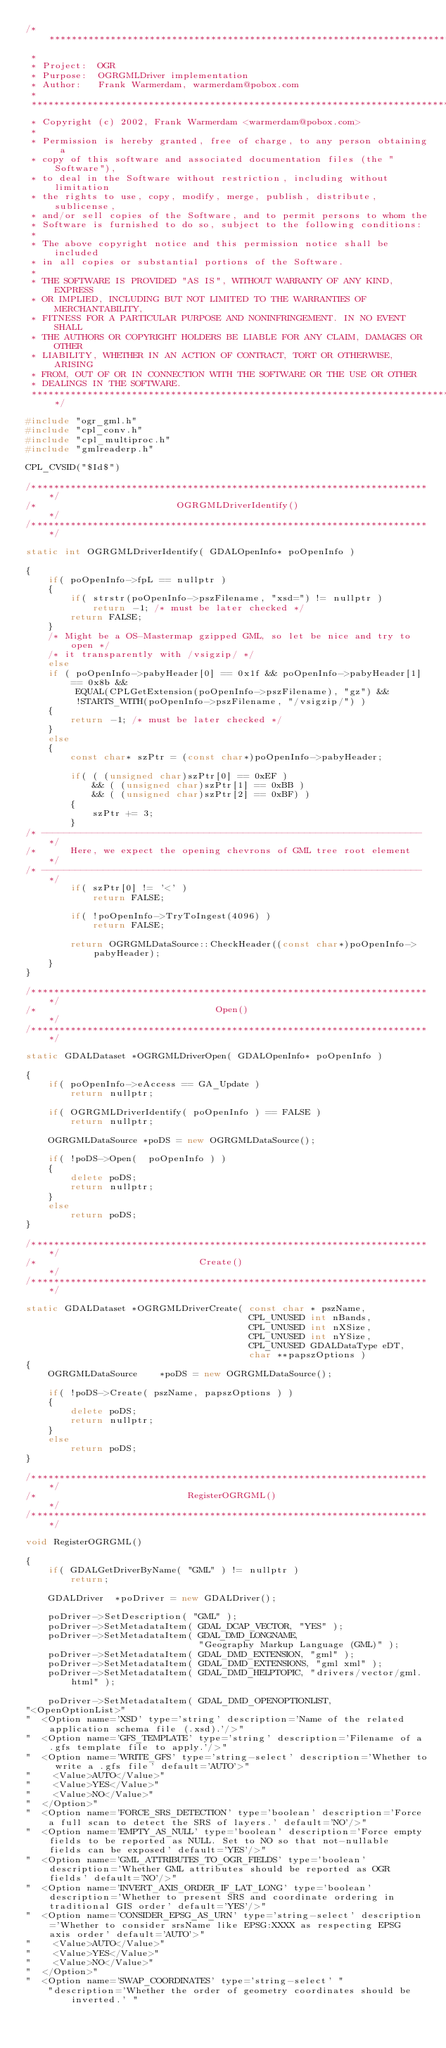Convert code to text. <code><loc_0><loc_0><loc_500><loc_500><_C++_>/******************************************************************************
 *
 * Project:  OGR
 * Purpose:  OGRGMLDriver implementation
 * Author:   Frank Warmerdam, warmerdam@pobox.com
 *
 ******************************************************************************
 * Copyright (c) 2002, Frank Warmerdam <warmerdam@pobox.com>
 *
 * Permission is hereby granted, free of charge, to any person obtaining a
 * copy of this software and associated documentation files (the "Software"),
 * to deal in the Software without restriction, including without limitation
 * the rights to use, copy, modify, merge, publish, distribute, sublicense,
 * and/or sell copies of the Software, and to permit persons to whom the
 * Software is furnished to do so, subject to the following conditions:
 *
 * The above copyright notice and this permission notice shall be included
 * in all copies or substantial portions of the Software.
 *
 * THE SOFTWARE IS PROVIDED "AS IS", WITHOUT WARRANTY OF ANY KIND, EXPRESS
 * OR IMPLIED, INCLUDING BUT NOT LIMITED TO THE WARRANTIES OF MERCHANTABILITY,
 * FITNESS FOR A PARTICULAR PURPOSE AND NONINFRINGEMENT. IN NO EVENT SHALL
 * THE AUTHORS OR COPYRIGHT HOLDERS BE LIABLE FOR ANY CLAIM, DAMAGES OR OTHER
 * LIABILITY, WHETHER IN AN ACTION OF CONTRACT, TORT OR OTHERWISE, ARISING
 * FROM, OUT OF OR IN CONNECTION WITH THE SOFTWARE OR THE USE OR OTHER
 * DEALINGS IN THE SOFTWARE.
 ****************************************************************************/

#include "ogr_gml.h"
#include "cpl_conv.h"
#include "cpl_multiproc.h"
#include "gmlreaderp.h"

CPL_CVSID("$Id$")

/************************************************************************/
/*                         OGRGMLDriverIdentify()                       */
/************************************************************************/

static int OGRGMLDriverIdentify( GDALOpenInfo* poOpenInfo )

{
    if( poOpenInfo->fpL == nullptr )
    {
        if( strstr(poOpenInfo->pszFilename, "xsd=") != nullptr )
            return -1; /* must be later checked */
        return FALSE;
    }
    /* Might be a OS-Mastermap gzipped GML, so let be nice and try to open */
    /* it transparently with /vsigzip/ */
    else
    if ( poOpenInfo->pabyHeader[0] == 0x1f && poOpenInfo->pabyHeader[1] == 0x8b &&
         EQUAL(CPLGetExtension(poOpenInfo->pszFilename), "gz") &&
         !STARTS_WITH(poOpenInfo->pszFilename, "/vsigzip/") )
    {
        return -1; /* must be later checked */
    }
    else
    {
        const char* szPtr = (const char*)poOpenInfo->pabyHeader;

        if( ( (unsigned char)szPtr[0] == 0xEF )
            && ( (unsigned char)szPtr[1] == 0xBB )
            && ( (unsigned char)szPtr[2] == 0xBF) )
        {
            szPtr += 3;
        }
/* -------------------------------------------------------------------- */
/*      Here, we expect the opening chevrons of GML tree root element   */
/* -------------------------------------------------------------------- */
        if( szPtr[0] != '<' )
            return FALSE;

        if( !poOpenInfo->TryToIngest(4096) )
            return FALSE;

        return OGRGMLDataSource::CheckHeader((const char*)poOpenInfo->pabyHeader);
    }
}

/************************************************************************/
/*                                Open()                                */
/************************************************************************/

static GDALDataset *OGRGMLDriverOpen( GDALOpenInfo* poOpenInfo )

{
    if( poOpenInfo->eAccess == GA_Update )
        return nullptr;

    if( OGRGMLDriverIdentify( poOpenInfo ) == FALSE )
        return nullptr;

    OGRGMLDataSource *poDS = new OGRGMLDataSource();

    if( !poDS->Open(  poOpenInfo ) )
    {
        delete poDS;
        return nullptr;
    }
    else
        return poDS;
}

/************************************************************************/
/*                             Create()                                 */
/************************************************************************/

static GDALDataset *OGRGMLDriverCreate( const char * pszName,
                                        CPL_UNUSED int nBands,
                                        CPL_UNUSED int nXSize,
                                        CPL_UNUSED int nYSize,
                                        CPL_UNUSED GDALDataType eDT,
                                        char **papszOptions )
{
    OGRGMLDataSource    *poDS = new OGRGMLDataSource();

    if( !poDS->Create( pszName, papszOptions ) )
    {
        delete poDS;
        return nullptr;
    }
    else
        return poDS;
}

/************************************************************************/
/*                           RegisterOGRGML()                           */
/************************************************************************/

void RegisterOGRGML()

{
    if( GDALGetDriverByName( "GML" ) != nullptr )
        return;

    GDALDriver  *poDriver = new GDALDriver();

    poDriver->SetDescription( "GML" );
    poDriver->SetMetadataItem( GDAL_DCAP_VECTOR, "YES" );
    poDriver->SetMetadataItem( GDAL_DMD_LONGNAME,
                               "Geography Markup Language (GML)" );
    poDriver->SetMetadataItem( GDAL_DMD_EXTENSION, "gml" );
    poDriver->SetMetadataItem( GDAL_DMD_EXTENSIONS, "gml xml" );
    poDriver->SetMetadataItem( GDAL_DMD_HELPTOPIC, "drivers/vector/gml.html" );

    poDriver->SetMetadataItem( GDAL_DMD_OPENOPTIONLIST,
"<OpenOptionList>"
"  <Option name='XSD' type='string' description='Name of the related application schema file (.xsd).'/>"
"  <Option name='GFS_TEMPLATE' type='string' description='Filename of a .gfs template file to apply.'/>"
"  <Option name='WRITE_GFS' type='string-select' description='Whether to write a .gfs file' default='AUTO'>"
"    <Value>AUTO</Value>"
"    <Value>YES</Value>"
"    <Value>NO</Value>"
"  </Option>"
"  <Option name='FORCE_SRS_DETECTION' type='boolean' description='Force a full scan to detect the SRS of layers.' default='NO'/>"
"  <Option name='EMPTY_AS_NULL' type='boolean' description='Force empty fields to be reported as NULL. Set to NO so that not-nullable fields can be exposed' default='YES'/>"
"  <Option name='GML_ATTRIBUTES_TO_OGR_FIELDS' type='boolean' description='Whether GML attributes should be reported as OGR fields' default='NO'/>"
"  <Option name='INVERT_AXIS_ORDER_IF_LAT_LONG' type='boolean' description='Whether to present SRS and coordinate ordering in traditional GIS order' default='YES'/>"
"  <Option name='CONSIDER_EPSG_AS_URN' type='string-select' description='Whether to consider srsName like EPSG:XXXX as respecting EPSG axis order' default='AUTO'>"
"    <Value>AUTO</Value>"
"    <Value>YES</Value>"
"    <Value>NO</Value>"
"  </Option>"
"  <Option name='SWAP_COORDINATES' type='string-select' "
    "description='Whether the order of geometry coordinates should be inverted.' "</code> 